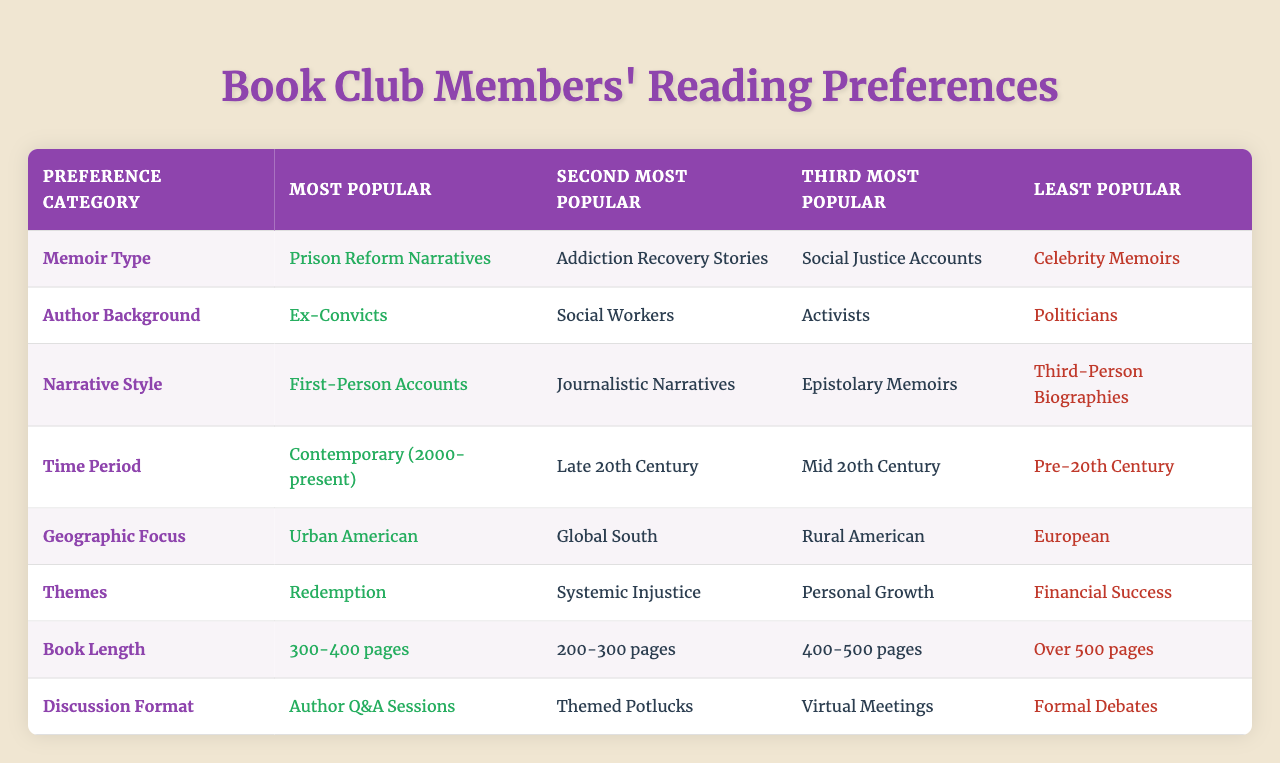What is the most popular type of memoir among book club members? The table shows that the most popular memoir type is "Prison Reform Narratives." This is explicitly stated in the "Most Popular" column under "Memoir Type."
Answer: Prison Reform Narratives Which author background is least popular according to the table? The table indicates that "Politicians" is listed as the least popular author background in the "Least Popular" column under "Author Background."
Answer: Politicians What theme is second most popular in readers' preferences? According to the "Most Popular" and "Second Most Popular" columns under "Themes," the second most popular theme is "Systemic Injustice."
Answer: Systemic Injustice How many different narrative styles are mentioned in the table? The table presents four narrative styles: "First-Person Accounts," "Journalistic Narratives," "Epistolary Memoirs," and "Third-Person Biographies," which shows that there are four styles total.
Answer: Four Which time period is the least popular for memoirs? In the "Least Popular" column under the "Time Period" category, "Pre-20th Century" is listed as the least popular time period for memoirs.
Answer: Pre-20th Century Do book club members prefer memoirs from the Urban American geographic focus over those from the European geographic focus? The table indicates that "Urban American" is the most popular geographic focus, while "European" is the least popular. This indicates a clear preference for Urban American over European.
Answer: Yes What is the difference between the most and least popular book lengths? The most popular book length is "300-400 pages," and the least popular is "Over 500 pages." This represents a difference in preference for book length because the most preferred range is shorter than the least, showcasing a clear gap instead of numerical values.
Answer: Yes Which format do members prefer for discussions? The "Most Popular" discussion format listed is "Author Q&A Sessions," which indicates that this is the preferred method for discussions among book club members.
Answer: Author Q&A Sessions If the three most popular themes are combined, which theme would not be included? The three most popular themes are "Redemption," "Systemic Injustice," and "Personal Growth." Therefore, "Financial Success," which is the least popular, would not be included when combining the three most popular themes.
Answer: Financial Success Calculating the average popularity across all book lengths listed would result in which conclusion? Since the book lengths listed are "300-400 pages," "200-300 pages," "400-500 pages," and "Over 500 pages," the average calculation shows a clear preference for the 300-400 pages range, which is confirmed based on the "Most Popular" column.
Answer: 300-400 pages is the average preference 